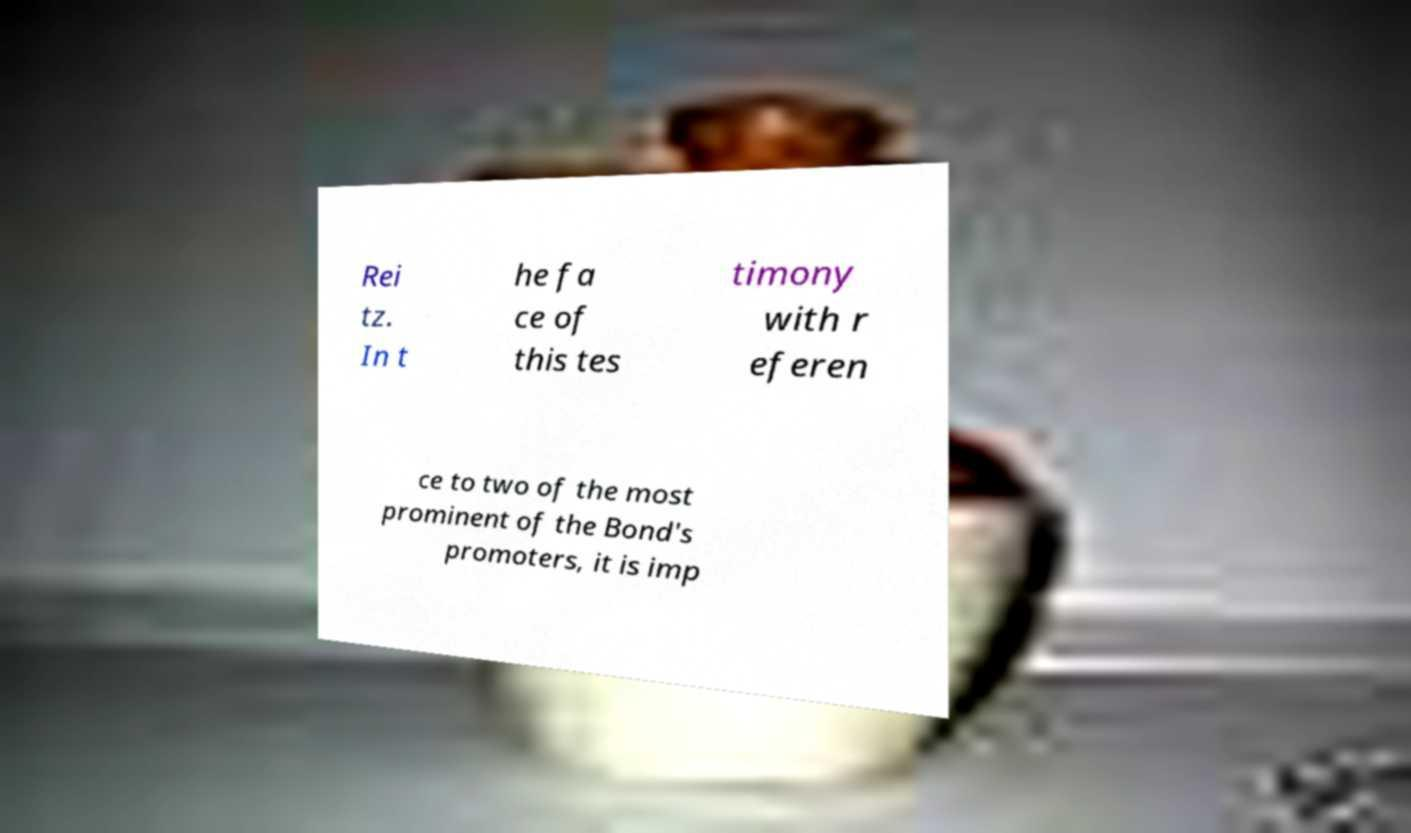Can you read and provide the text displayed in the image?This photo seems to have some interesting text. Can you extract and type it out for me? Rei tz. In t he fa ce of this tes timony with r eferen ce to two of the most prominent of the Bond's promoters, it is imp 